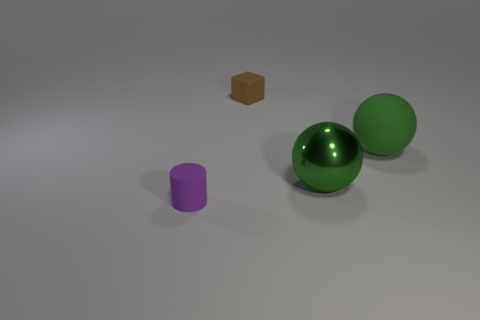Subtract all gray cylinders. Subtract all red cubes. How many cylinders are left? 1 Add 3 small blue spheres. How many objects exist? 7 Subtract all cubes. How many objects are left? 3 Subtract all large purple metallic objects. Subtract all big green matte objects. How many objects are left? 3 Add 2 big matte things. How many big matte things are left? 3 Add 4 green spheres. How many green spheres exist? 6 Subtract 0 red spheres. How many objects are left? 4 